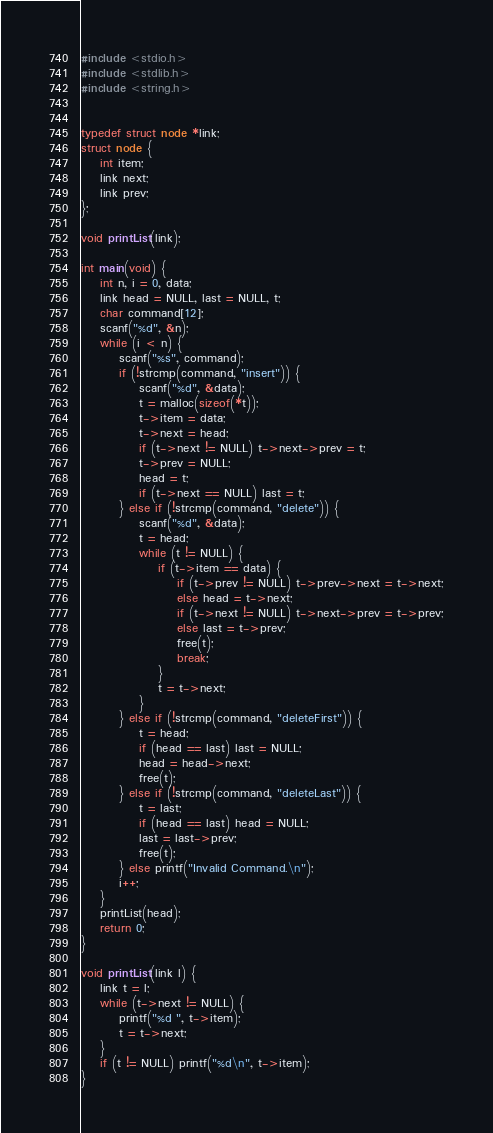<code> <loc_0><loc_0><loc_500><loc_500><_C_>#include <stdio.h>
#include <stdlib.h>
#include <string.h>


typedef struct node *link;
struct node {
    int item;
    link next;
    link prev;
};

void printList(link);

int main(void) {
    int n, i = 0, data;
    link head = NULL, last = NULL, t;
    char command[12];
    scanf("%d", &n);
    while (i < n) {
        scanf("%s", command);
        if (!strcmp(command, "insert")) {
            scanf("%d", &data);
            t = malloc(sizeof(*t));
            t->item = data;
            t->next = head;
            if (t->next != NULL) t->next->prev = t;
            t->prev = NULL;
            head = t;
            if (t->next == NULL) last = t;
        } else if (!strcmp(command, "delete")) {
            scanf("%d", &data);
            t = head;
            while (t != NULL) {
                if (t->item == data) {
                    if (t->prev != NULL) t->prev->next = t->next;
                    else head = t->next;
                    if (t->next != NULL) t->next->prev = t->prev;
                    else last = t->prev;
                    free(t);
                    break;
                }
                t = t->next;
            }
        } else if (!strcmp(command, "deleteFirst")) {
            t = head;
            if (head == last) last = NULL;
            head = head->next;
            free(t);
        } else if (!strcmp(command, "deleteLast")) {
            t = last;
            if (head == last) head = NULL;
            last = last->prev;
            free(t);
        } else printf("Invalid Command.\n");
        i++;
    }
    printList(head);
    return 0;
}

void printList(link l) {
    link t = l;
    while (t->next != NULL) {
        printf("%d ", t->item);
        t = t->next;
    }
    if (t != NULL) printf("%d\n", t->item);
}</code> 